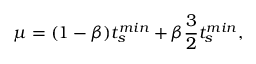Convert formula to latex. <formula><loc_0><loc_0><loc_500><loc_500>\mu = ( 1 - \beta ) t _ { s } ^ { \min } + \beta \frac { 3 } { 2 } t _ { s } ^ { \min } ,</formula> 